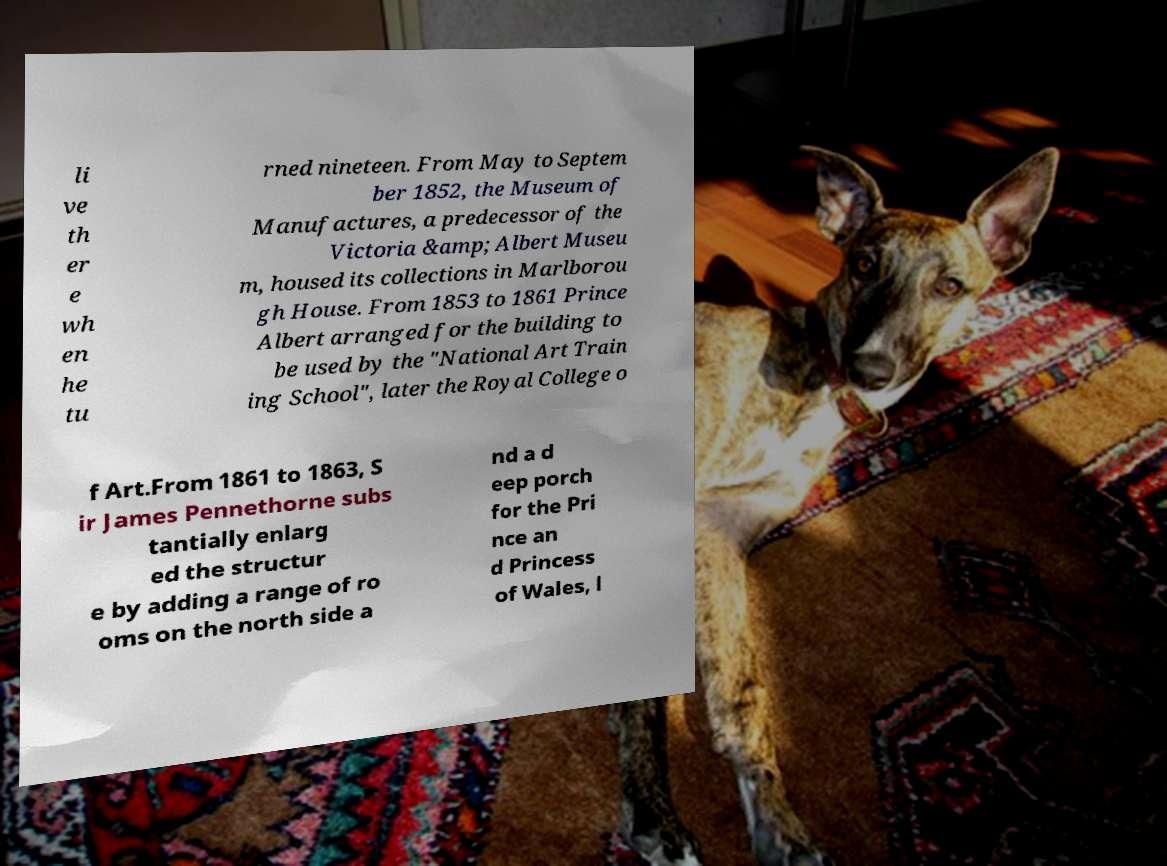Can you accurately transcribe the text from the provided image for me? li ve th er e wh en he tu rned nineteen. From May to Septem ber 1852, the Museum of Manufactures, a predecessor of the Victoria &amp; Albert Museu m, housed its collections in Marlborou gh House. From 1853 to 1861 Prince Albert arranged for the building to be used by the "National Art Train ing School", later the Royal College o f Art.From 1861 to 1863, S ir James Pennethorne subs tantially enlarg ed the structur e by adding a range of ro oms on the north side a nd a d eep porch for the Pri nce an d Princess of Wales, l 